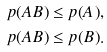<formula> <loc_0><loc_0><loc_500><loc_500>p ( A B ) & \leq p ( A ) , \\ p ( A B ) & \leq p ( B ) .</formula> 